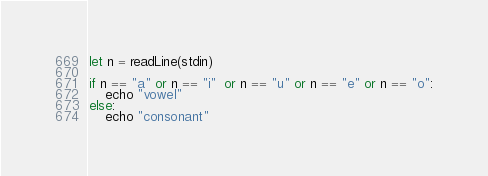<code> <loc_0><loc_0><loc_500><loc_500><_Nim_>let n = readLine(stdin)

if n == "a" or n == "i"  or n == "u" or n == "e" or n == "o":
    echo "vowel"
else:
    echo "consonant"</code> 